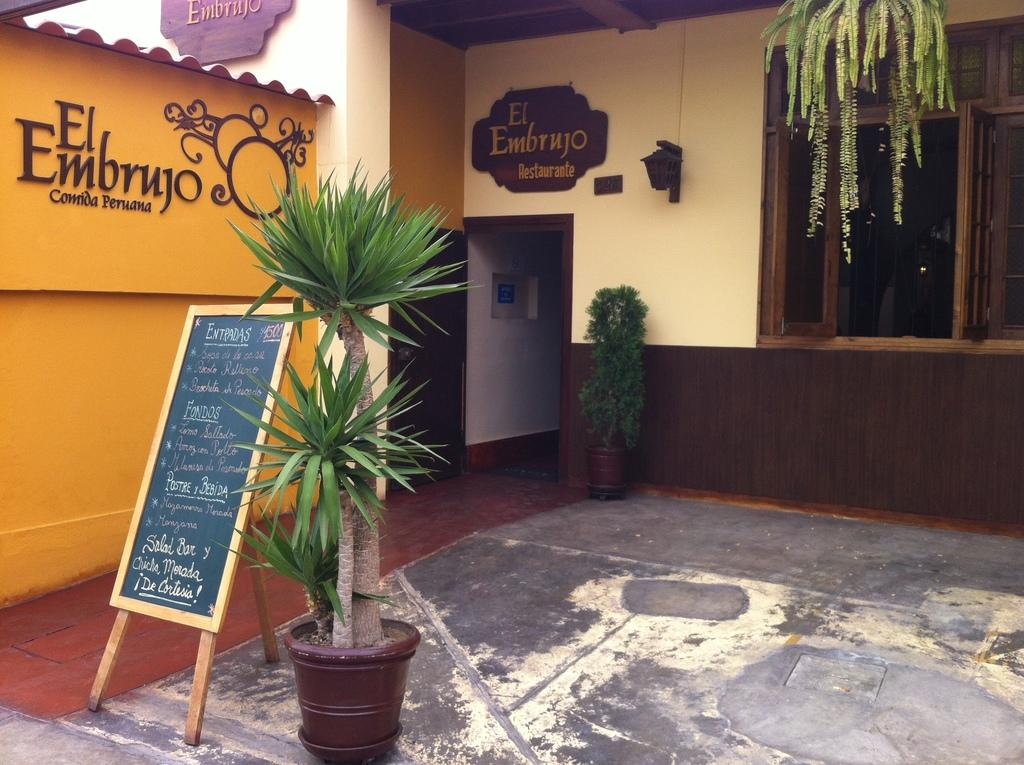What type of structure is visible in the image? There is a house in the image. What other objects can be seen in the image? There are plants, a pot, a board, and windows visible in the image. How many children are arguing about the pipe in the image? There are no children or pipes present in the image. 